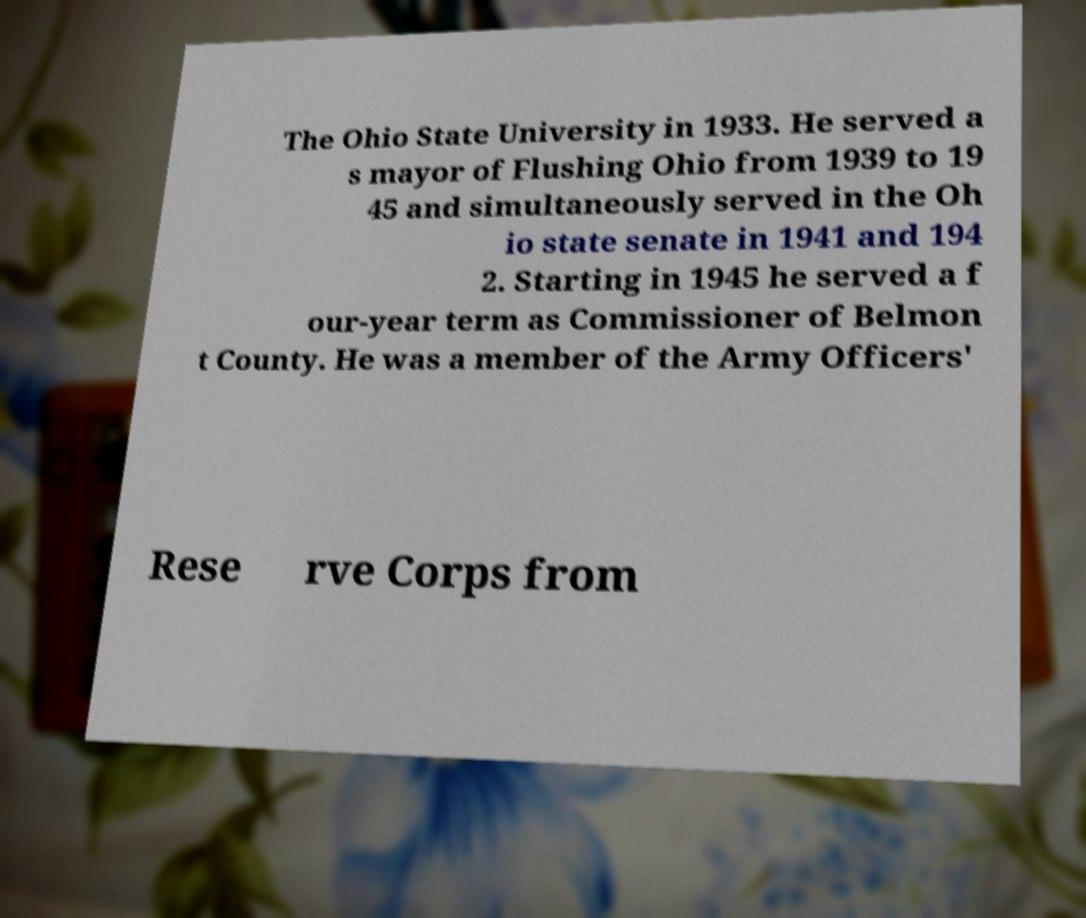For documentation purposes, I need the text within this image transcribed. Could you provide that? The Ohio State University in 1933. He served a s mayor of Flushing Ohio from 1939 to 19 45 and simultaneously served in the Oh io state senate in 1941 and 194 2. Starting in 1945 he served a f our-year term as Commissioner of Belmon t County. He was a member of the Army Officers' Rese rve Corps from 